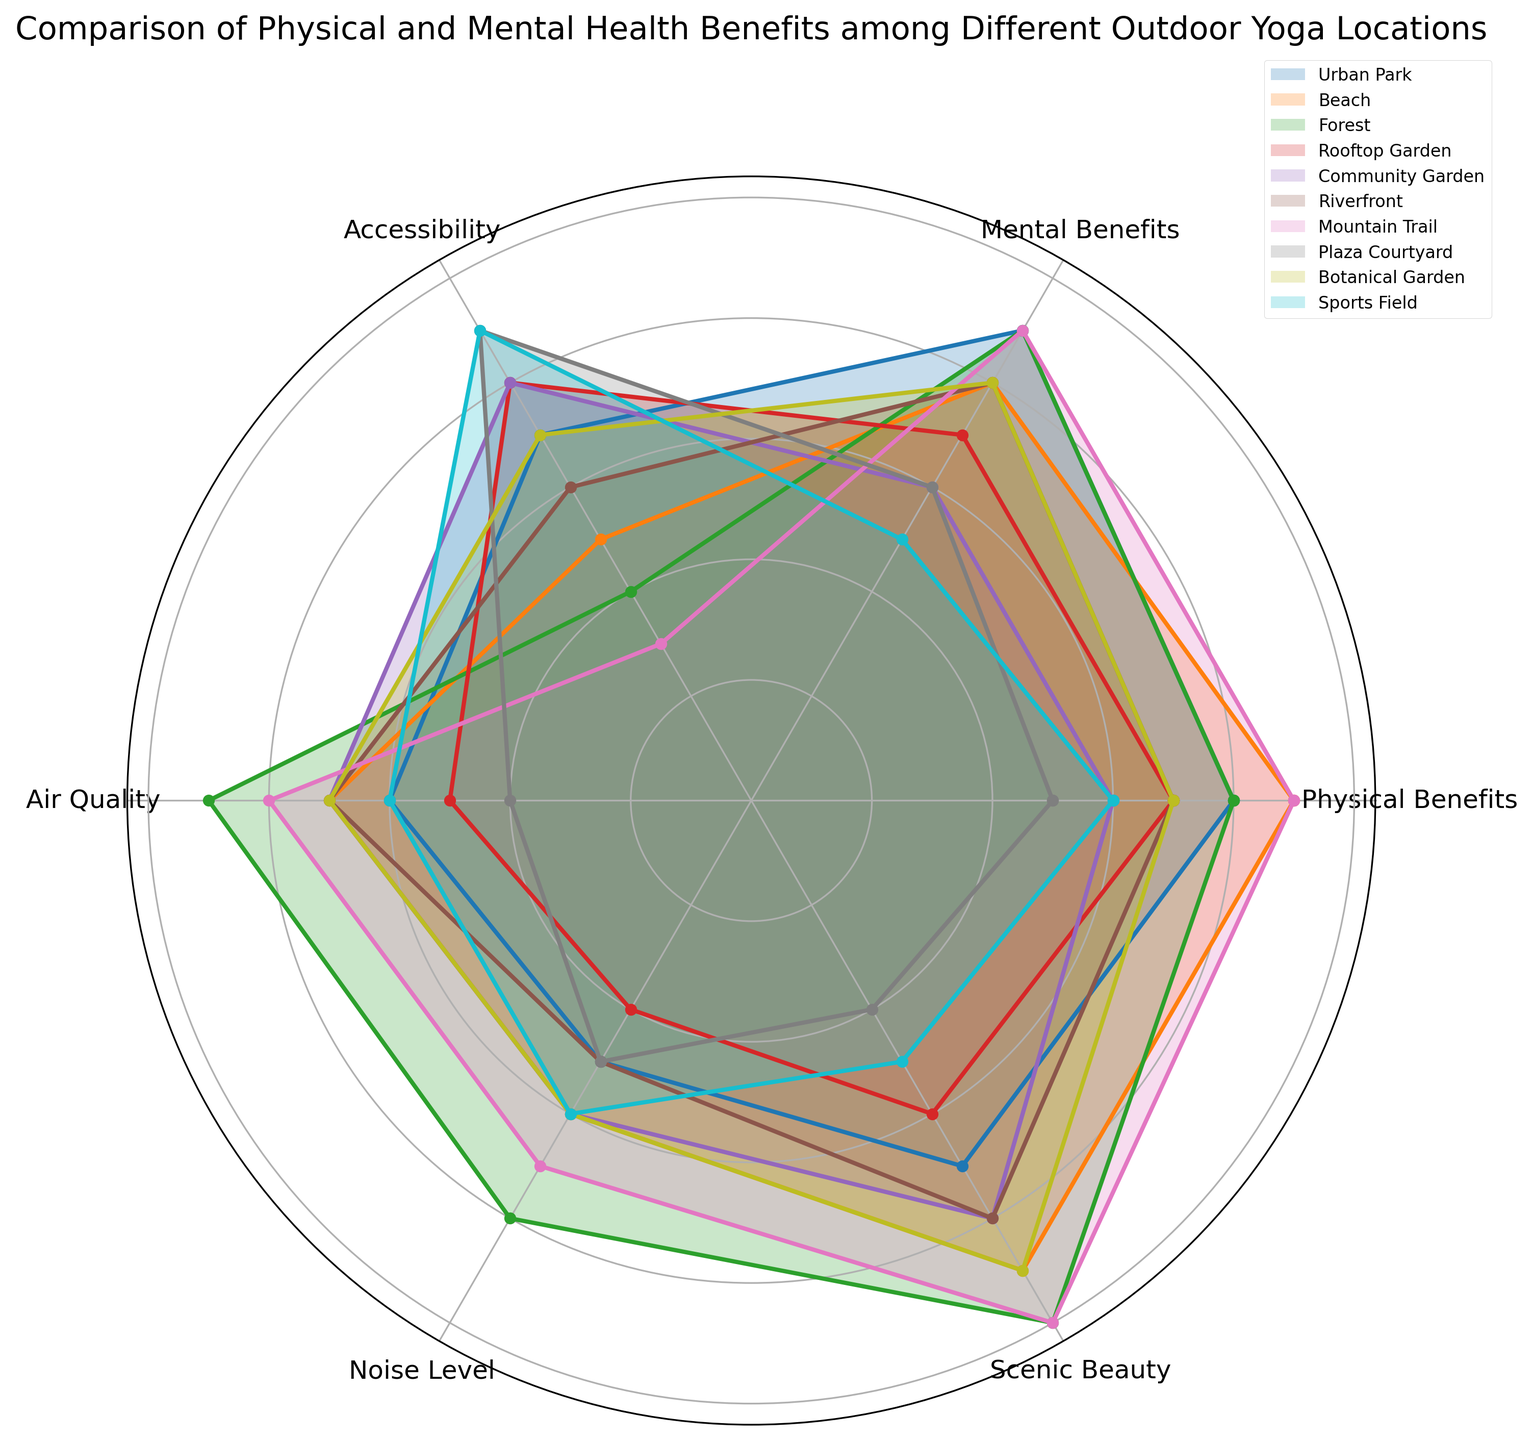Which location offers the highest scenic beauty? Scenic beauty is represented by the radial distance on the chart. The location with the highest radial distance in scenic beauty is identified easily.
Answer: Mountain Trail Which two locations have the highest physical and mental benefits combined? The two locations with the highest combined physical and mental benefits are those where the sum of physical and mental benefits' radial lengths is the greatest.
Answer: Forest and Mountain Trail Does the Beach location provide better air quality or noise level? To determine this, compare the radial distances for air quality and noise level for the Beach location.
Answer: Air Quality Which location has the best air quality? Locate the radial distance corresponding to air quality; the location with the highest value on this axis is the answer.
Answer: Forest What is the difference in accessibility between Urban Park and Mountain Trail? Subtract the accessibility score of the Mountain Trail from that of the Urban Park by comparing their radial distances.
Answer: 4 Which location has the highest accessibility but the lowest noise level? Identify the location that ranks highest on the accessibility axis and lowest on the noise level axis.
Answer: Plaza Courtyard How does the physical benefit of a Community Garden compare to that of a Sports Field? Compare the radial distances of physical benefits for both the Community Garden and Sports Field.
Answer: Higher Which location offers the highest overall benefits (sum of all categories)? Calculate the sum of all categorical scores for each location and compare them.
Answer: Mountain Trail Is the scenic beauty of the Rooftop Garden higher or lower than the Beach? Compare the radial distances for scenic beauty between Rooftop Garden and Beach.
Answer: Lower What is the average noise level rating across all locations? Sum up the noise level ratings for all locations and divide by the total number of locations.
Answer: 5.5 